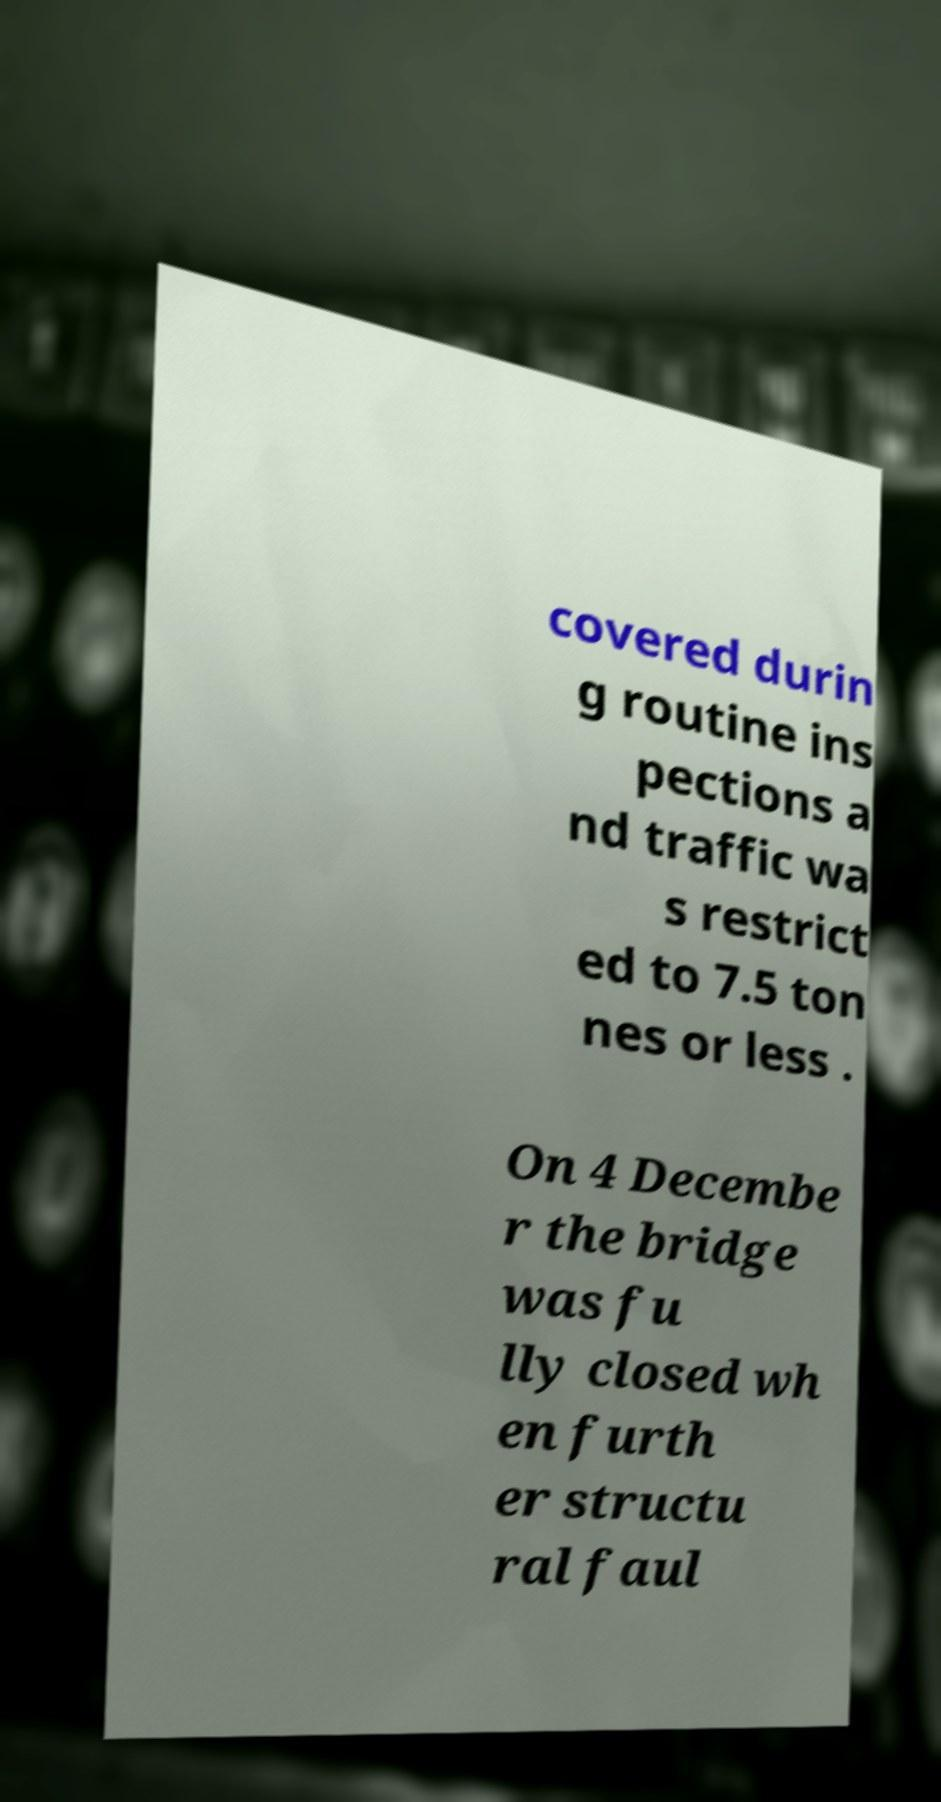I need the written content from this picture converted into text. Can you do that? covered durin g routine ins pections a nd traffic wa s restrict ed to 7.5 ton nes or less . On 4 Decembe r the bridge was fu lly closed wh en furth er structu ral faul 